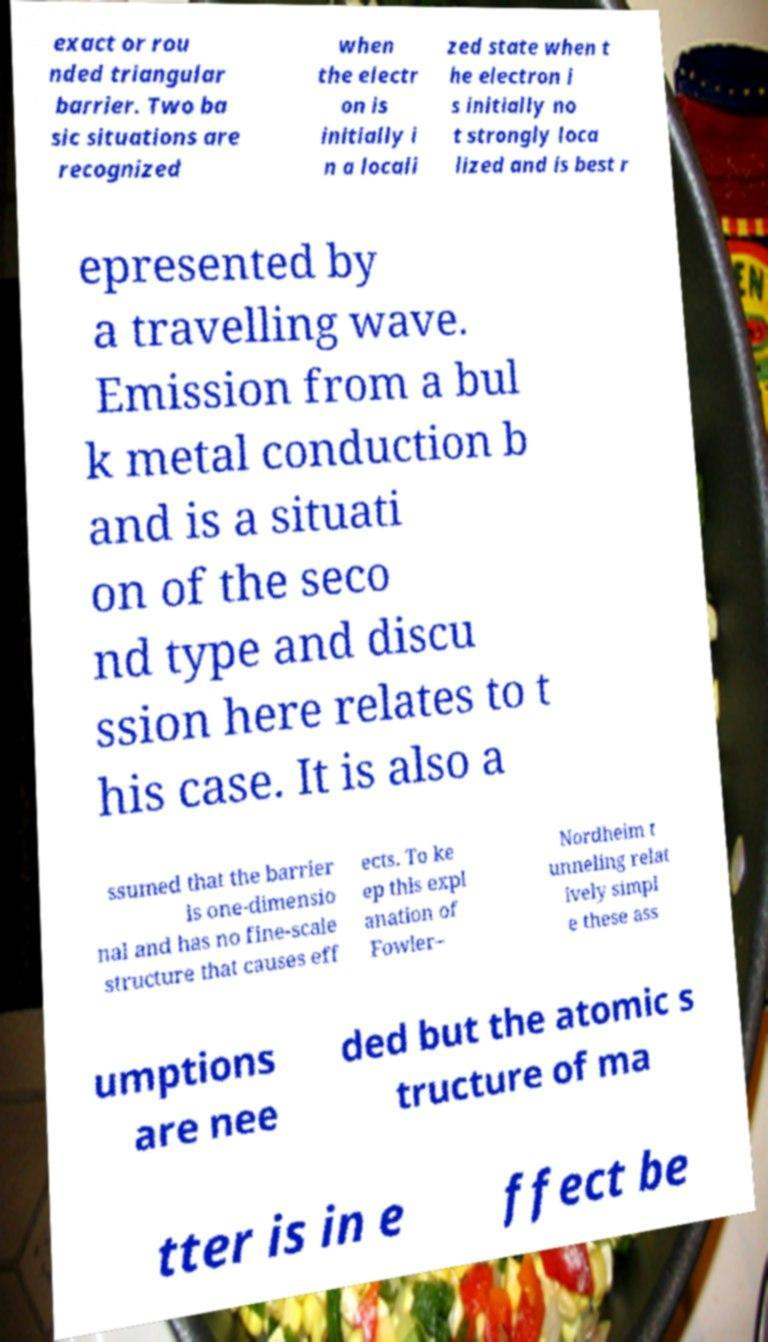Could you extract and type out the text from this image? exact or rou nded triangular barrier. Two ba sic situations are recognized when the electr on is initially i n a locali zed state when t he electron i s initially no t strongly loca lized and is best r epresented by a travelling wave. Emission from a bul k metal conduction b and is a situati on of the seco nd type and discu ssion here relates to t his case. It is also a ssumed that the barrier is one-dimensio nal and has no fine-scale structure that causes eff ects. To ke ep this expl anation of Fowler– Nordheim t unneling relat ively simpl e these ass umptions are nee ded but the atomic s tructure of ma tter is in e ffect be 